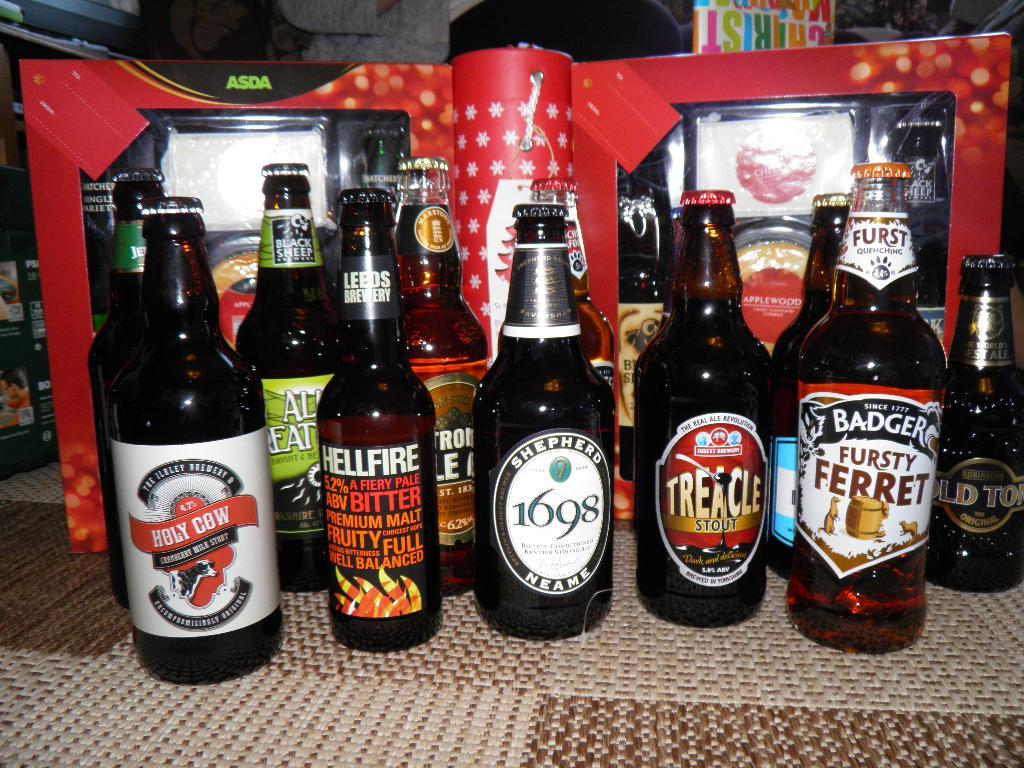<image>
Offer a succinct explanation of the picture presented. bottles of alcohol in a row with one of them labeled 'fursty ferret' 